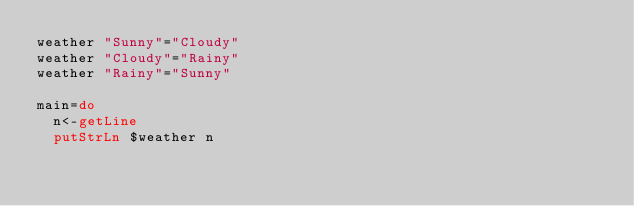<code> <loc_0><loc_0><loc_500><loc_500><_Haskell_>weather "Sunny"="Cloudy"
weather "Cloudy"="Rainy"
weather "Rainy"="Sunny"

main=do
  n<-getLine
  putStrLn $weather n
</code> 